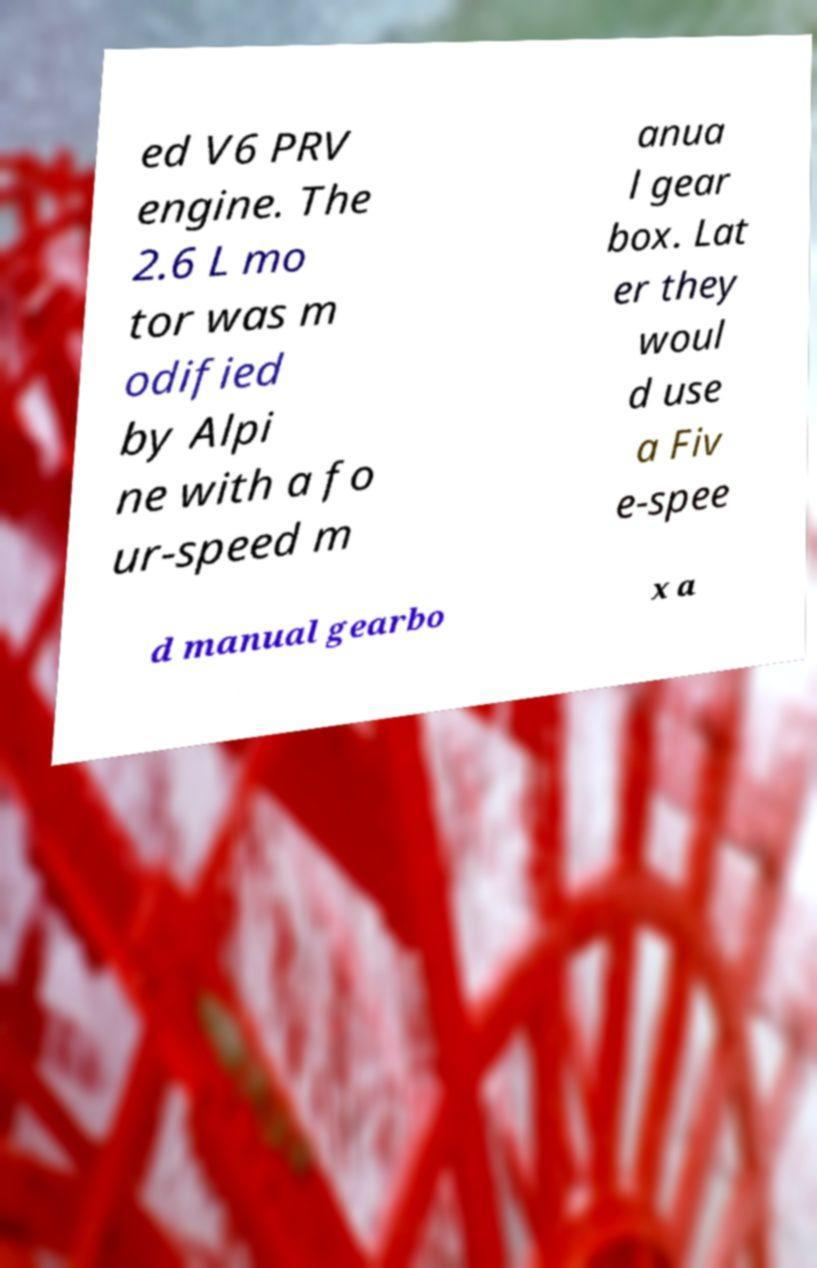Could you extract and type out the text from this image? ed V6 PRV engine. The 2.6 L mo tor was m odified by Alpi ne with a fo ur-speed m anua l gear box. Lat er they woul d use a Fiv e-spee d manual gearbo x a 